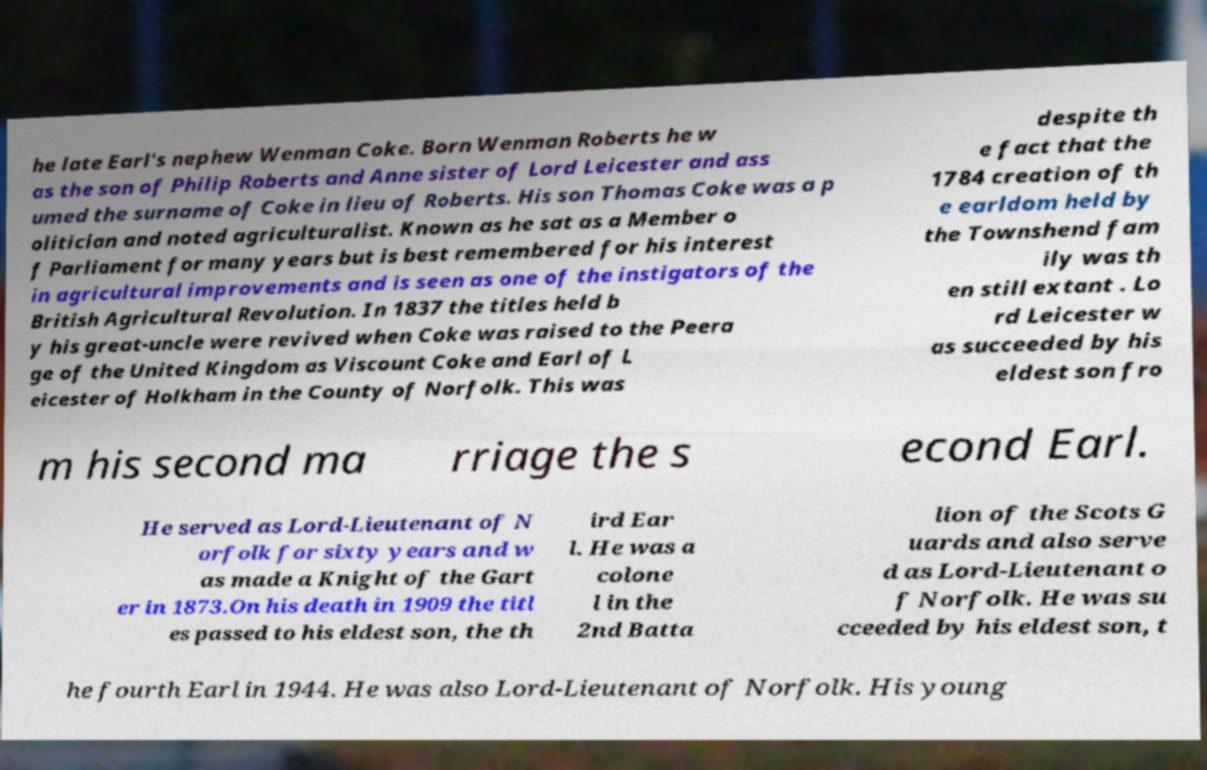Please read and relay the text visible in this image. What does it say? he late Earl's nephew Wenman Coke. Born Wenman Roberts he w as the son of Philip Roberts and Anne sister of Lord Leicester and ass umed the surname of Coke in lieu of Roberts. His son Thomas Coke was a p olitician and noted agriculturalist. Known as he sat as a Member o f Parliament for many years but is best remembered for his interest in agricultural improvements and is seen as one of the instigators of the British Agricultural Revolution. In 1837 the titles held b y his great-uncle were revived when Coke was raised to the Peera ge of the United Kingdom as Viscount Coke and Earl of L eicester of Holkham in the County of Norfolk. This was despite th e fact that the 1784 creation of th e earldom held by the Townshend fam ily was th en still extant . Lo rd Leicester w as succeeded by his eldest son fro m his second ma rriage the s econd Earl. He served as Lord-Lieutenant of N orfolk for sixty years and w as made a Knight of the Gart er in 1873.On his death in 1909 the titl es passed to his eldest son, the th ird Ear l. He was a colone l in the 2nd Batta lion of the Scots G uards and also serve d as Lord-Lieutenant o f Norfolk. He was su cceeded by his eldest son, t he fourth Earl in 1944. He was also Lord-Lieutenant of Norfolk. His young 